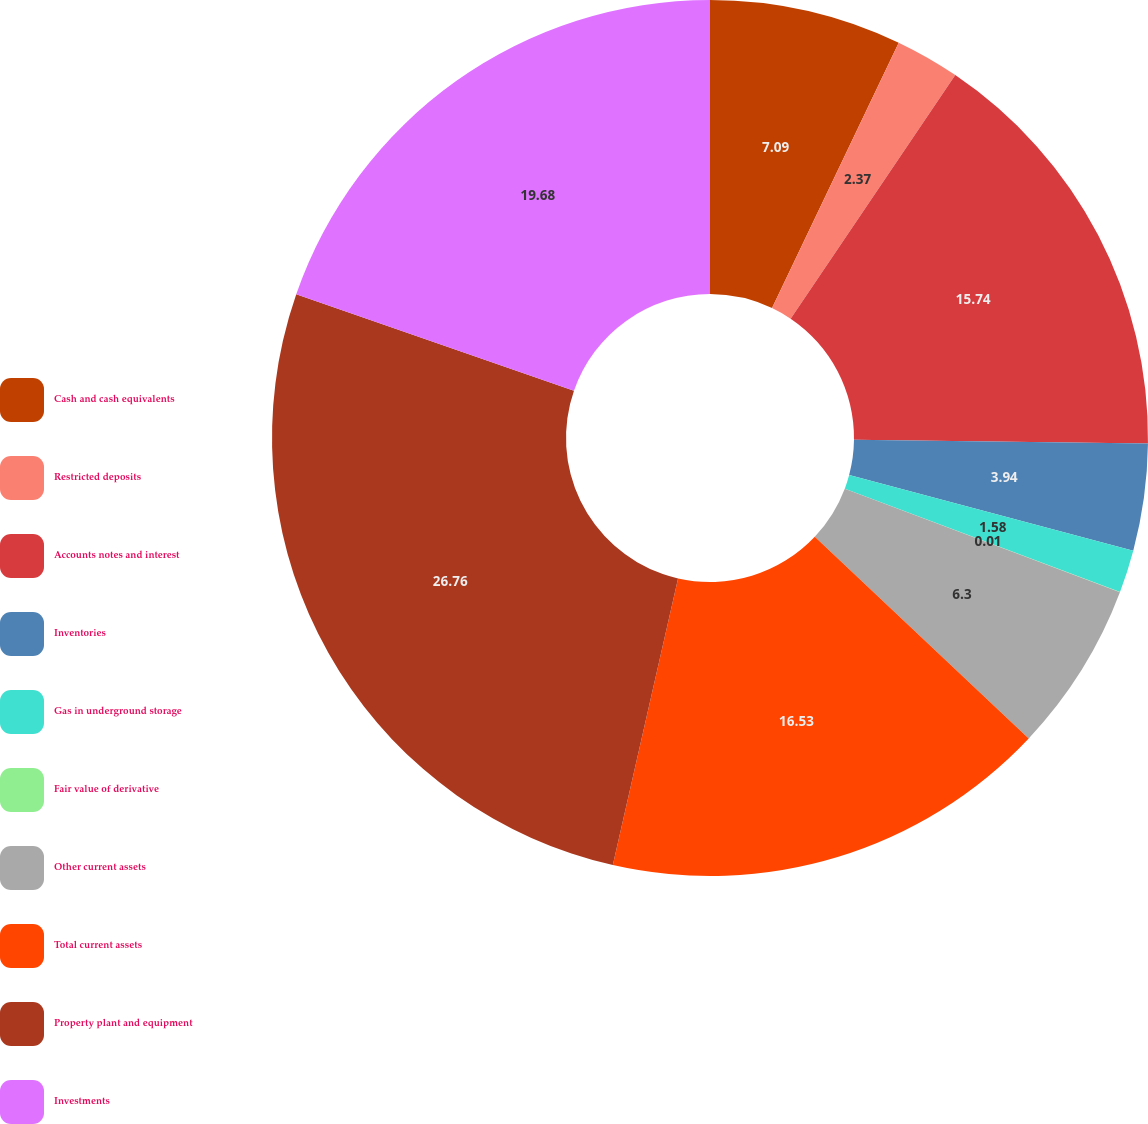Convert chart to OTSL. <chart><loc_0><loc_0><loc_500><loc_500><pie_chart><fcel>Cash and cash equivalents<fcel>Restricted deposits<fcel>Accounts notes and interest<fcel>Inventories<fcel>Gas in underground storage<fcel>Fair value of derivative<fcel>Other current assets<fcel>Total current assets<fcel>Property plant and equipment<fcel>Investments<nl><fcel>7.09%<fcel>2.37%<fcel>15.74%<fcel>3.94%<fcel>1.58%<fcel>0.01%<fcel>6.3%<fcel>16.53%<fcel>26.76%<fcel>19.68%<nl></chart> 